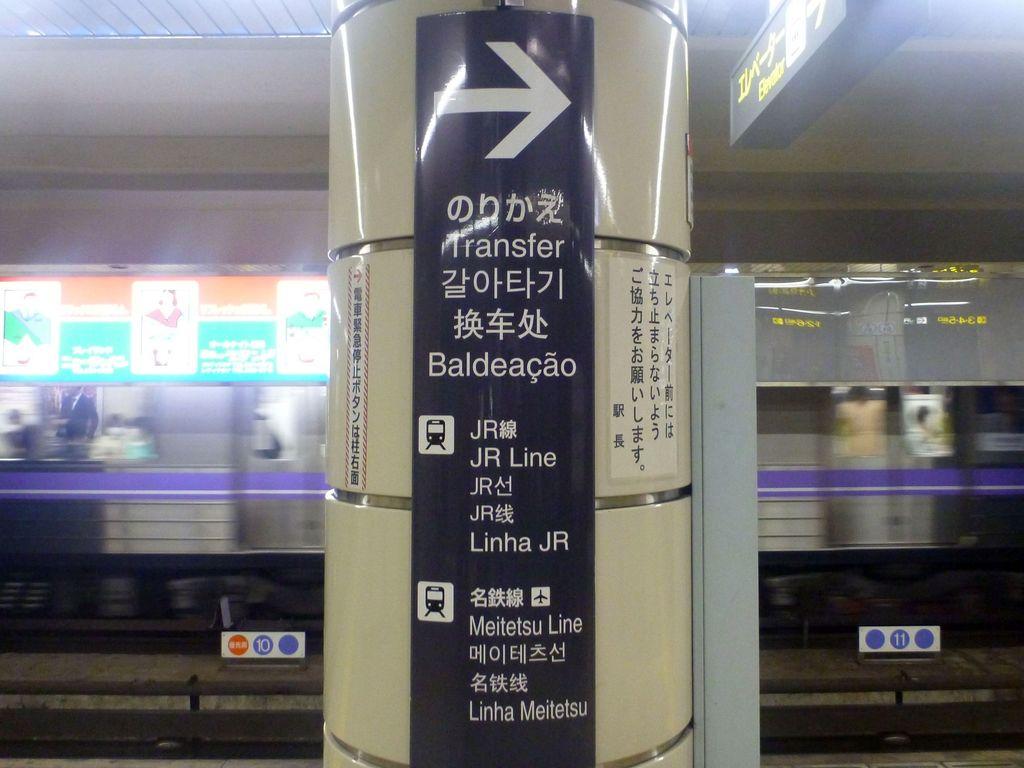Which way is transfer?
Offer a very short reply. Right. What is the name of the first line on the sign?
Offer a terse response. Transfer. 